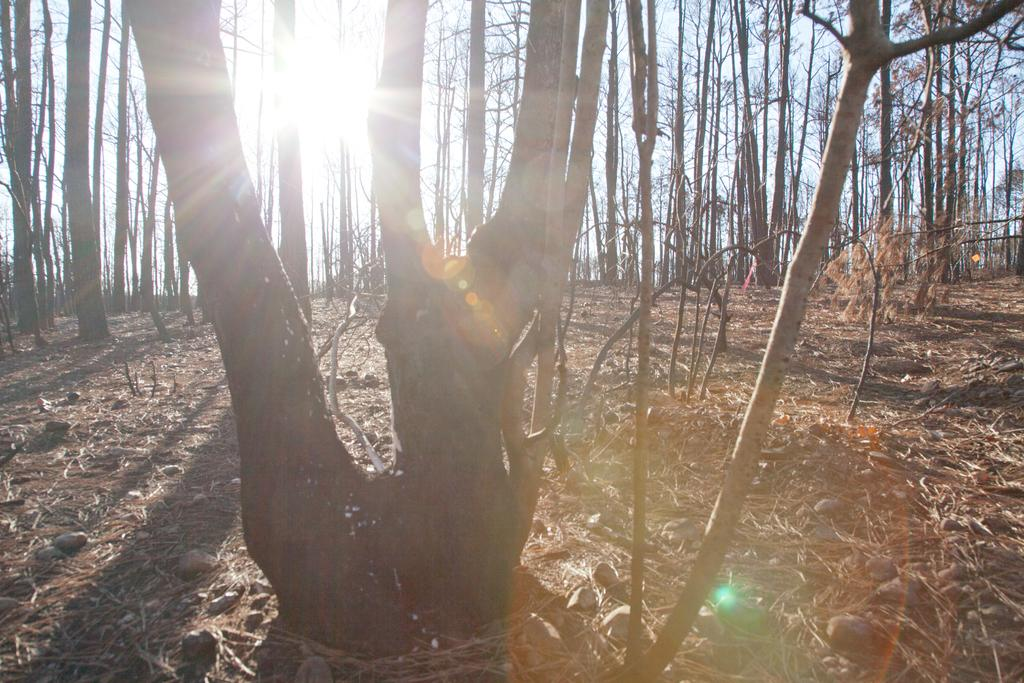What type of natural elements can be seen in the image? There are trees in the image. What can be found at the bottom of the image? There are stones and leaves at the bottom of the image. What celestial body is visible in the background of the image? The Sun is visible in the background of the image. What else can be seen in the background of the image? The sky is visible in the background of the image. What type of wire is used to create the form of the marble sculpture in the image? There is no wire or marble sculpture present in the image. 